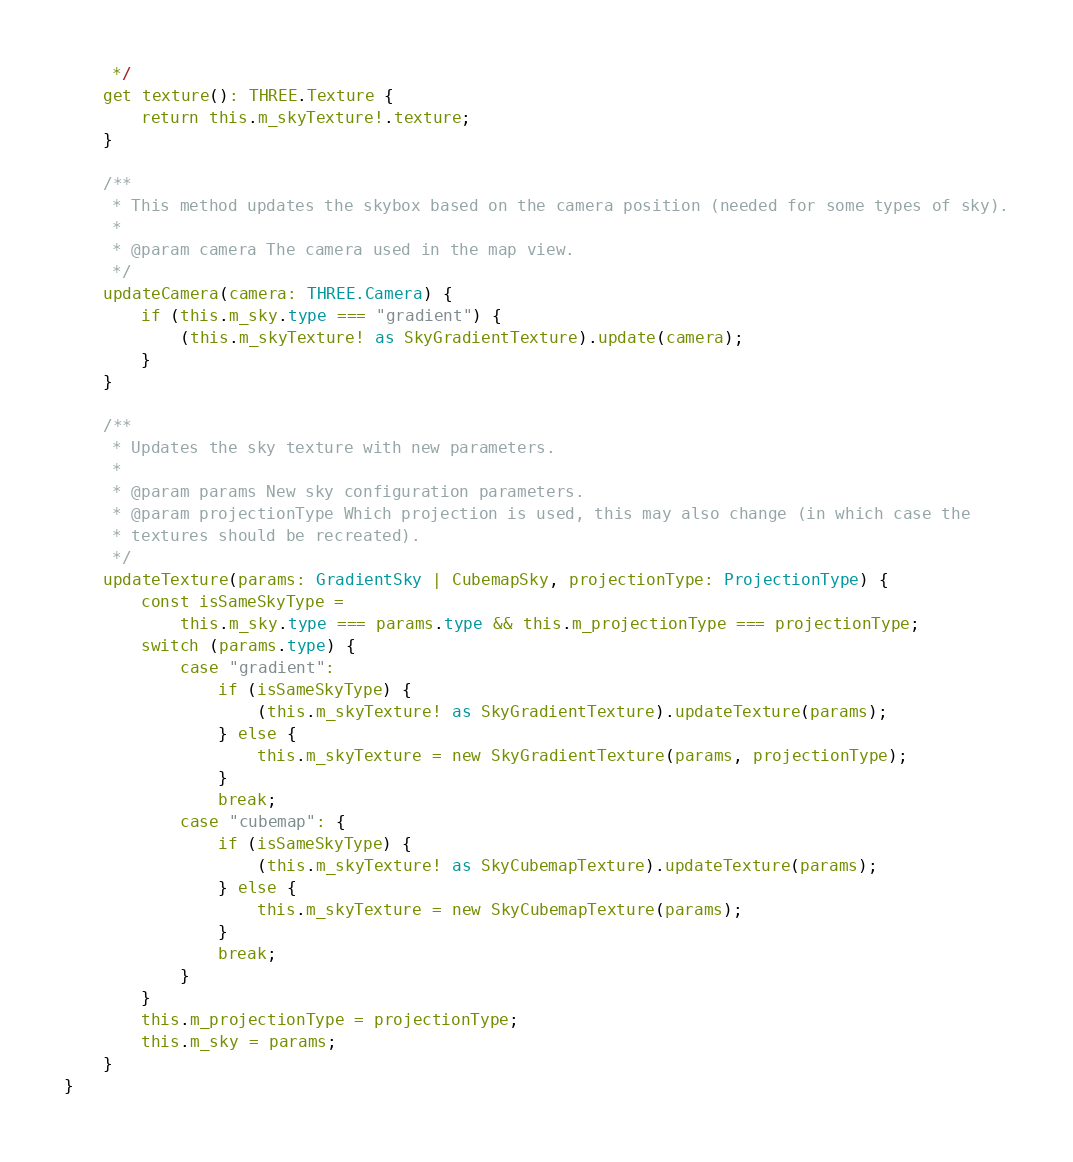<code> <loc_0><loc_0><loc_500><loc_500><_TypeScript_>     */
    get texture(): THREE.Texture {
        return this.m_skyTexture!.texture;
    }

    /**
     * This method updates the skybox based on the camera position (needed for some types of sky).
     *
     * @param camera The camera used in the map view.
     */
    updateCamera(camera: THREE.Camera) {
        if (this.m_sky.type === "gradient") {
            (this.m_skyTexture! as SkyGradientTexture).update(camera);
        }
    }

    /**
     * Updates the sky texture with new parameters.
     *
     * @param params New sky configuration parameters.
     * @param projectionType Which projection is used, this may also change (in which case the
     * textures should be recreated).
     */
    updateTexture(params: GradientSky | CubemapSky, projectionType: ProjectionType) {
        const isSameSkyType =
            this.m_sky.type === params.type && this.m_projectionType === projectionType;
        switch (params.type) {
            case "gradient":
                if (isSameSkyType) {
                    (this.m_skyTexture! as SkyGradientTexture).updateTexture(params);
                } else {
                    this.m_skyTexture = new SkyGradientTexture(params, projectionType);
                }
                break;
            case "cubemap": {
                if (isSameSkyType) {
                    (this.m_skyTexture! as SkyCubemapTexture).updateTexture(params);
                } else {
                    this.m_skyTexture = new SkyCubemapTexture(params);
                }
                break;
            }
        }
        this.m_projectionType = projectionType;
        this.m_sky = params;
    }
}
</code> 